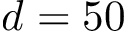Convert formula to latex. <formula><loc_0><loc_0><loc_500><loc_500>d = 5 0</formula> 